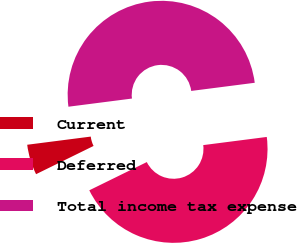Convert chart. <chart><loc_0><loc_0><loc_500><loc_500><pie_chart><fcel>Current<fcel>Deferred<fcel>Total income tax expense<nl><fcel>5.23%<fcel>44.77%<fcel>50.0%<nl></chart> 